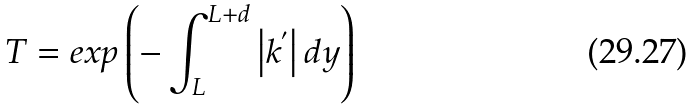<formula> <loc_0><loc_0><loc_500><loc_500>T = e x p \left ( - \int _ { L } ^ { L + d } \left | k ^ { ^ { \prime } } \right | d y \right )</formula> 